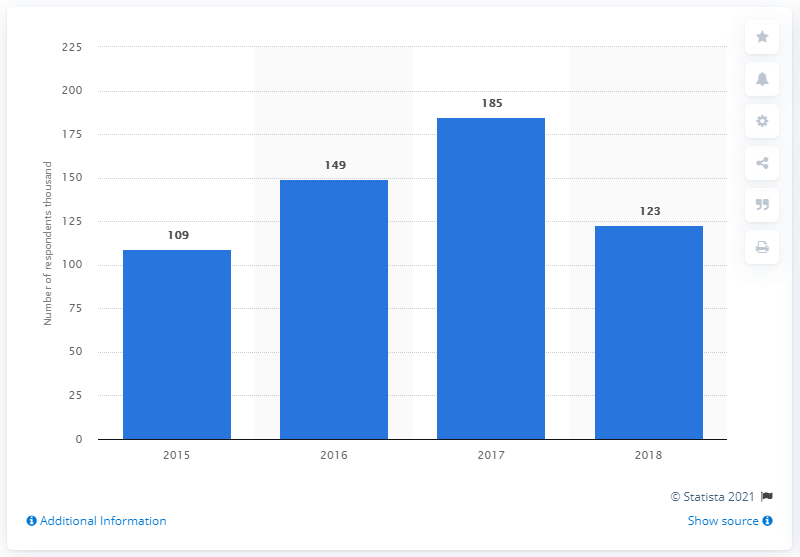Highlight a few significant elements in this photo. The ratio of the most participants to the least participants across all years is 1.697... In 2015, windsurfing experienced a significant increase in popularity in the United Kingdom. The second largest bar is 149. 